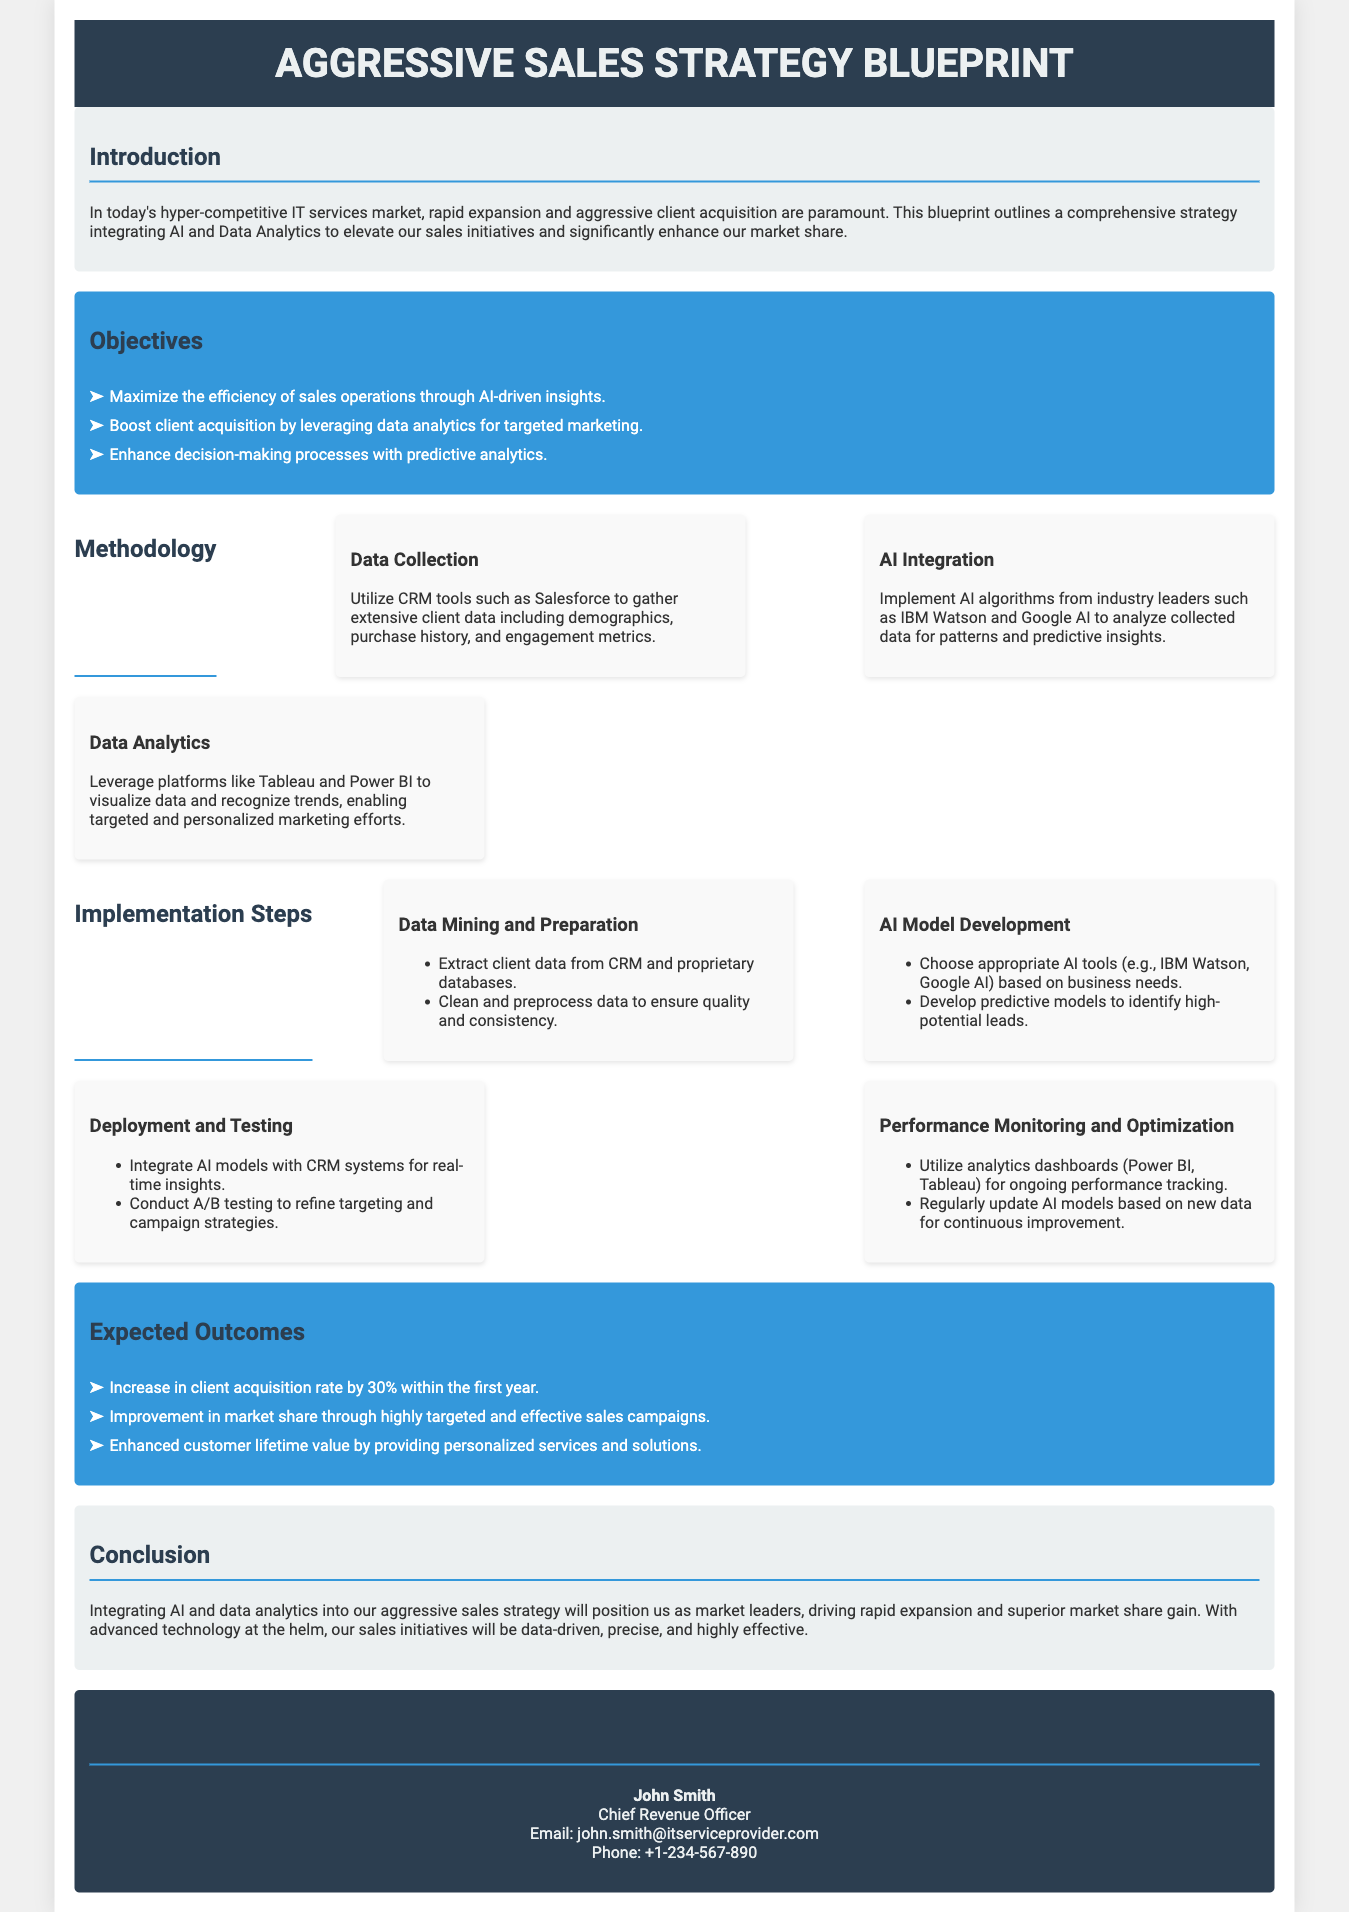what is the title of the document? The title of the document is specified in the header section.
Answer: Aggressive Sales Strategy Blueprint who is the Chief Revenue Officer? The Chief Revenue Officer's name is provided under contact information.
Answer: John Smith what is the expected increase in client acquisition rate? The expected increase is mentioned under the outcomes section.
Answer: 30% which AI tools are suggested for model development? The document lists appropriate tools for AI model development in the implementation section.
Answer: IBM Watson, Google AI what color is used for the objectives section? The objectives section's background color is described in the style section.
Answer: Blue what is the main focus of the introduction? The main focus of the introduction is given in the opening paragraph.
Answer: Rapid expansion and aggressive client acquisition how many implementation steps are outlined? The implementation section specifies the number of steps involved.
Answer: Four what analytics platforms are recommended for visualizing data? The document mentions specific platforms in the methodology section for data visualization.
Answer: Tableau, Power BI what is the conclusion about integrating AI and data analytics? The conclusion summarizes the impact of AI and data analytics integration in one sentence.
Answer: Market leaders, driving rapid expansion and superior market share gain 